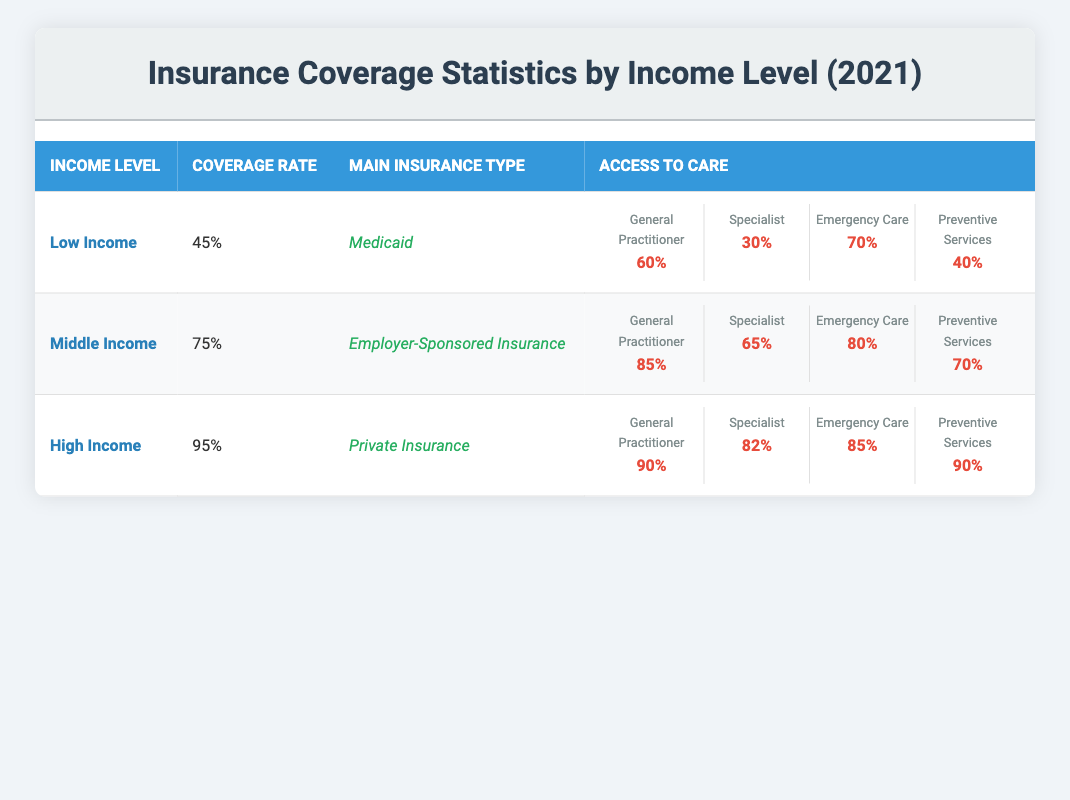What is the Coverage Rate for Low Income individuals? The table lists the Coverage Rate under the Low Income category as 45%.
Answer: 45% Which Main Insurance Type do Middle Income individuals primarily have? According to the table, Middle Income individuals primarily have Employer-Sponsored Insurance.
Answer: Employer-Sponsored Insurance What percentage of High Income individuals have access to General Practitioner services? The table shows that 90% of High Income individuals have access to General Practitioner services.
Answer: 90% Is the Coverage Rate for Middle Income individuals greater than that for Low Income individuals? The Coverage Rate for Middle Income individuals is 75%, while that for Low Income individuals is 45%. Since 75% is greater than 45%, the statement is true.
Answer: Yes What is the average percentage for access to Preventive Services across all income levels? The access to Preventive Services is 40% for Low Income, 70% for Middle Income, and 90% for High Income. To find the average: (40 + 70 + 90) / 3 = 200 / 3 = 66.67%.
Answer: 66.67% Which income level has the lowest access to Specialist services? From the table, Low Income individuals have 30% access to Specialist services, which is lower than the 65% for Middle Income and 82% for High Income.
Answer: Low Income If the Emergency Care access for Middle Income is compared to that of Low Income, which is higher and by how much? Middle Income has 80% access to Emergency Care while Low Income has 70%. The difference is 80% - 70% = 10%.
Answer: Higher by 10% Do High Income individuals have the highest access to Emergency Care? High Income individuals have 85% access to Emergency Care, which is higher than both Low Income (70%) and Middle Income (80%). Thus, they do indeed have the highest access.
Answer: Yes What are the coverage rates for Low Income and High Income individuals combined? The Coverage Rate for Low Income is 45% and for High Income is 95%. Combined, they are calculated as (45 + 95) = 140%.
Answer: 140% 